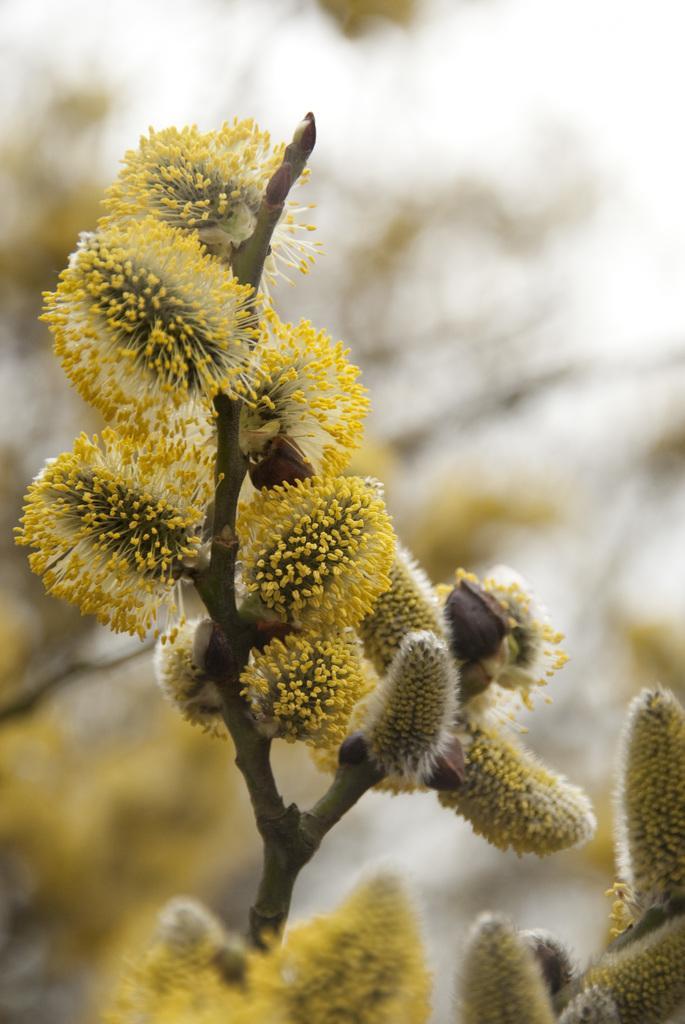Could you give a brief overview of what you see in this image? In this image I can see a tree to which I can see few flowers which are yellow and cream in color. In the background I can see few trees and the sky which are blurry. 